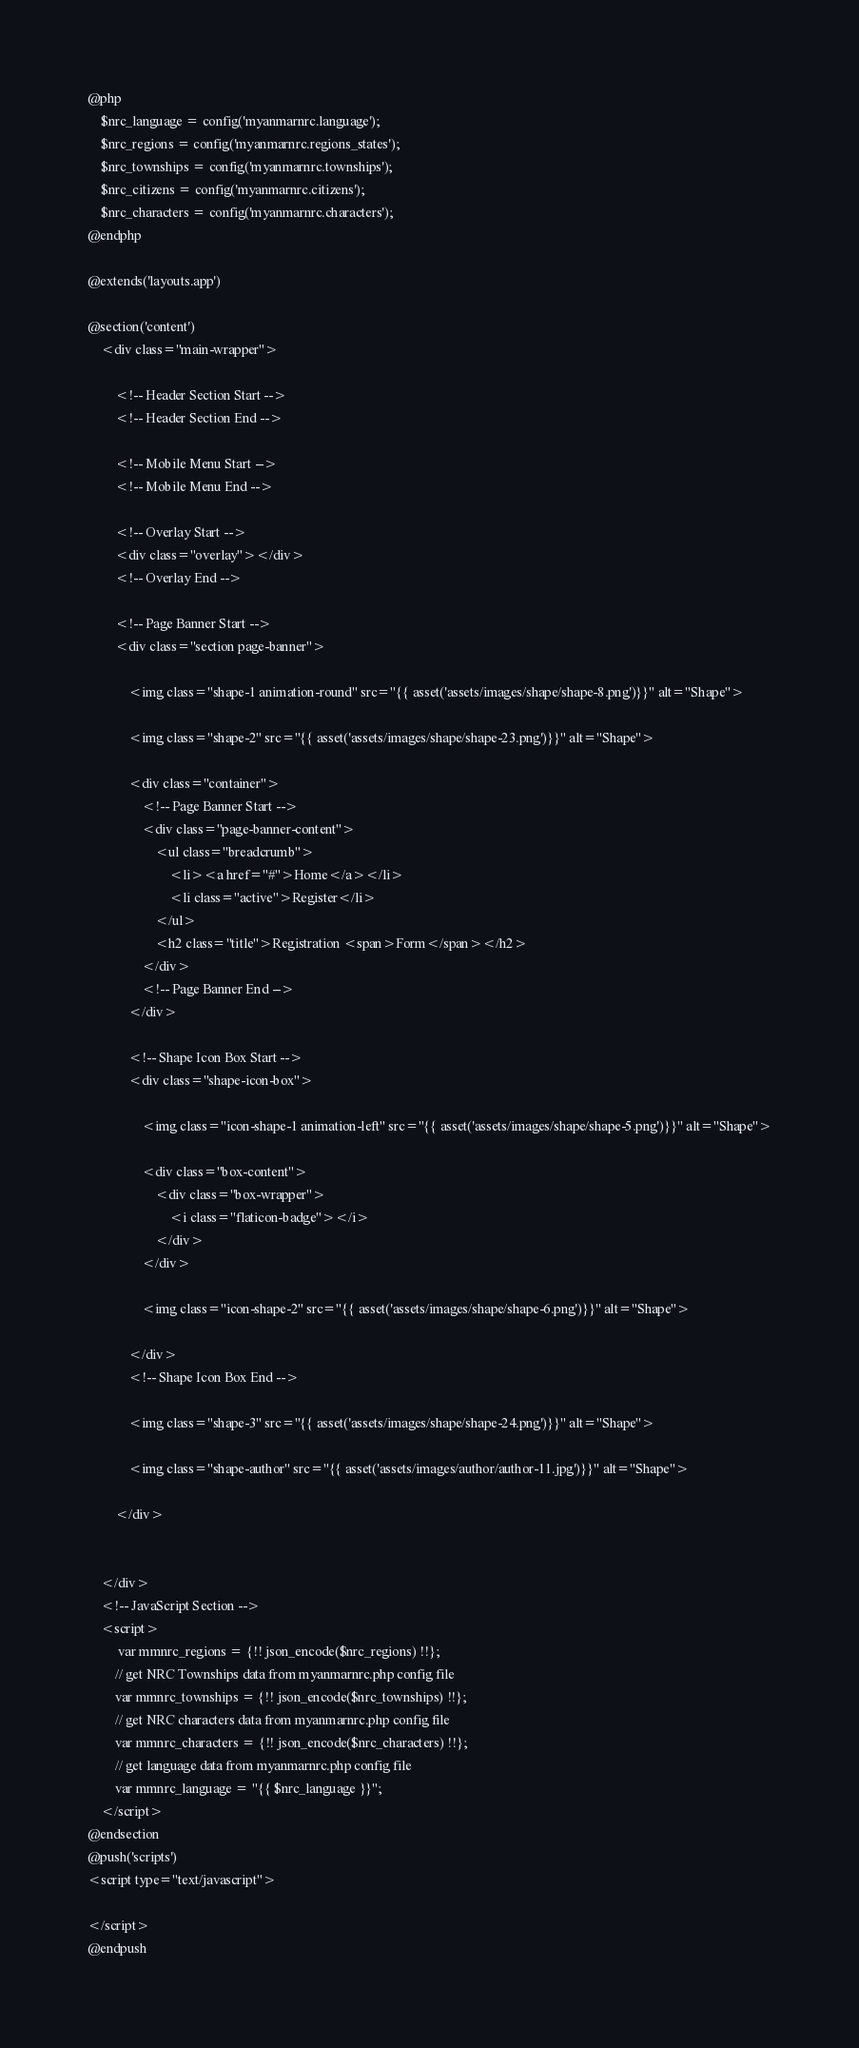<code> <loc_0><loc_0><loc_500><loc_500><_PHP_>@php
	$nrc_language = config('myanmarnrc.language');
	$nrc_regions = config('myanmarnrc.regions_states');
	$nrc_townships = config('myanmarnrc.townships');
	$nrc_citizens = config('myanmarnrc.citizens');
	$nrc_characters = config('myanmarnrc.characters');
@endphp

@extends('layouts.app')

@section('content')
    <div class="main-wrapper">

        <!-- Header Section Start -->
        <!-- Header Section End -->

        <!-- Mobile Menu Start -->
        <!-- Mobile Menu End -->

        <!-- Overlay Start -->
        <div class="overlay"></div>
        <!-- Overlay End -->

        <!-- Page Banner Start -->
        <div class="section page-banner">

            <img class="shape-1 animation-round" src="{{ asset('assets/images/shape/shape-8.png')}}" alt="Shape">

            <img class="shape-2" src="{{ asset('assets/images/shape/shape-23.png')}}" alt="Shape">

            <div class="container">
                <!-- Page Banner Start -->
                <div class="page-banner-content">
                    <ul class="breadcrumb">
                        <li><a href="#">Home</a></li>
                        <li class="active">Register</li>
                    </ul>
                    <h2 class="title">Registration <span>Form</span></h2>
                </div>
                <!-- Page Banner End -->
            </div>

            <!-- Shape Icon Box Start -->
            <div class="shape-icon-box">

                <img class="icon-shape-1 animation-left" src="{{ asset('assets/images/shape/shape-5.png')}}" alt="Shape">

                <div class="box-content">
                    <div class="box-wrapper">
                        <i class="flaticon-badge"></i>
                    </div>
                </div>

                <img class="icon-shape-2" src="{{ asset('assets/images/shape/shape-6.png')}}" alt="Shape">

            </div>
            <!-- Shape Icon Box End -->

            <img class="shape-3" src="{{ asset('assets/images/shape/shape-24.png')}}" alt="Shape">

            <img class="shape-author" src="{{ asset('assets/images/author/author-11.jpg')}}" alt="Shape">

        </div>

        
    </div>
    <!-- JavaScript Section -->
    <script>
         var mmnrc_regions = {!! json_encode($nrc_regions) !!};
        // get NRC Townships data from myanmarnrc.php config file
        var mmnrc_townships = {!! json_encode($nrc_townships) !!};
        // get NRC characters data from myanmarnrc.php config file
        var mmnrc_characters = {!! json_encode($nrc_characters) !!};
        // get language data from myanmarnrc.php config file
        var mmnrc_language = "{{ $nrc_language }}";
    </script>
@endsection
@push('scripts')
<script type="text/javascript">
   
</script>
@endpush</code> 